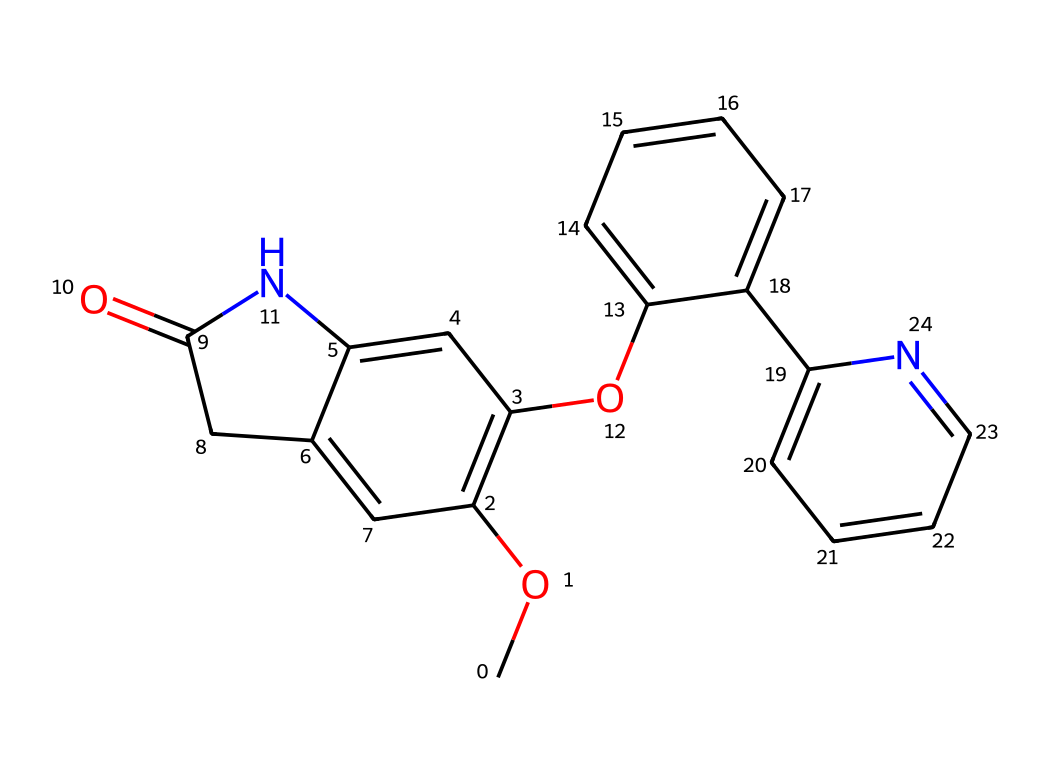What is the name of this chemical? The chemical represented by the provided SMILES is donepezil, which is used as a cholinesterase inhibitor in Alzheimer's treatment. The molecular structure's complexity indicates it has significant biological activity.
Answer: donepezil How many rings are present in the structure? Upon examining the SMILES representation, there are four distinct rings visible in the structure. Counting each cycle confirms this.
Answer: four Does this chemical contain any nitrogen atoms? The SMILES representation shows nitrogen atoms indicated by 'N' in the structure. A simple visual count reveals the presence of two nitrogen atoms.
Answer: two What functional group is present in this chemical? The chemical has several functional groups, but it notably contains an aromatic ring and a ketone group denoted by the 'C(=O)' part of the structure, indicating it is not a nitrile as might be initially thought.
Answer: ketone What is the molecular formula of this chemical? By analyzing the structure and counting the carbon, hydrogen, nitrogen, and oxygen atoms represented in the SMILES, we can derive the molecular formula C18H21N.
Answer: C18H21N Which part of this molecule contributes to its ability to inhibit cholinesterase? The nitrogen atoms within the cyclic structures play a crucial role in binding to the cholinesterase enzyme, enabling the inhibition process to occur. The aromatic nature also contributes to its effectiveness.
Answer: nitrogen Where in the structure is the ketone group located? The ketone group can be identified within the structure at the specific segment 'CC(=O)' in the SMILES, indicating its placement is adjacent to a cycloalkene structure.
Answer: adjacent to a cycloalkene 